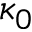Convert formula to latex. <formula><loc_0><loc_0><loc_500><loc_500>\kappa _ { 0 }</formula> 